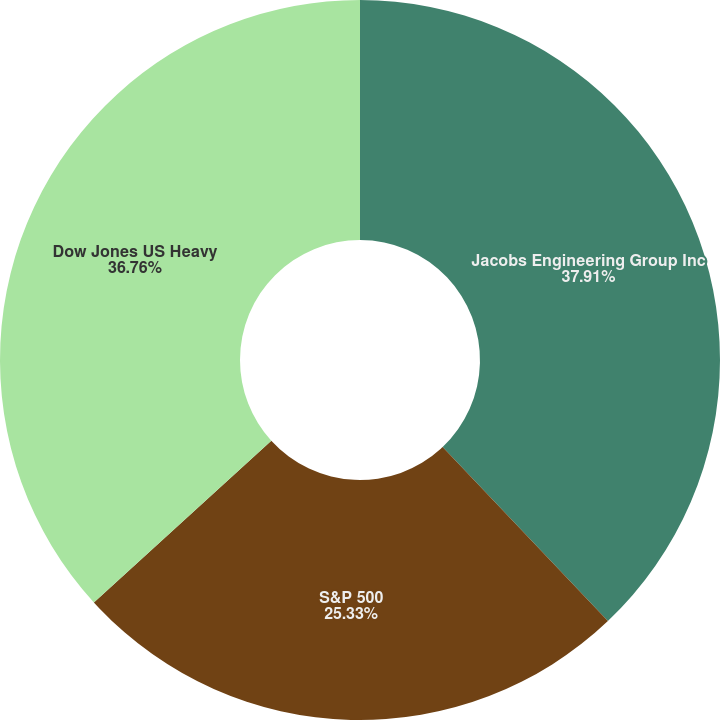Convert chart. <chart><loc_0><loc_0><loc_500><loc_500><pie_chart><fcel>Jacobs Engineering Group Inc<fcel>S&P 500<fcel>Dow Jones US Heavy<nl><fcel>37.91%<fcel>25.33%<fcel>36.76%<nl></chart> 